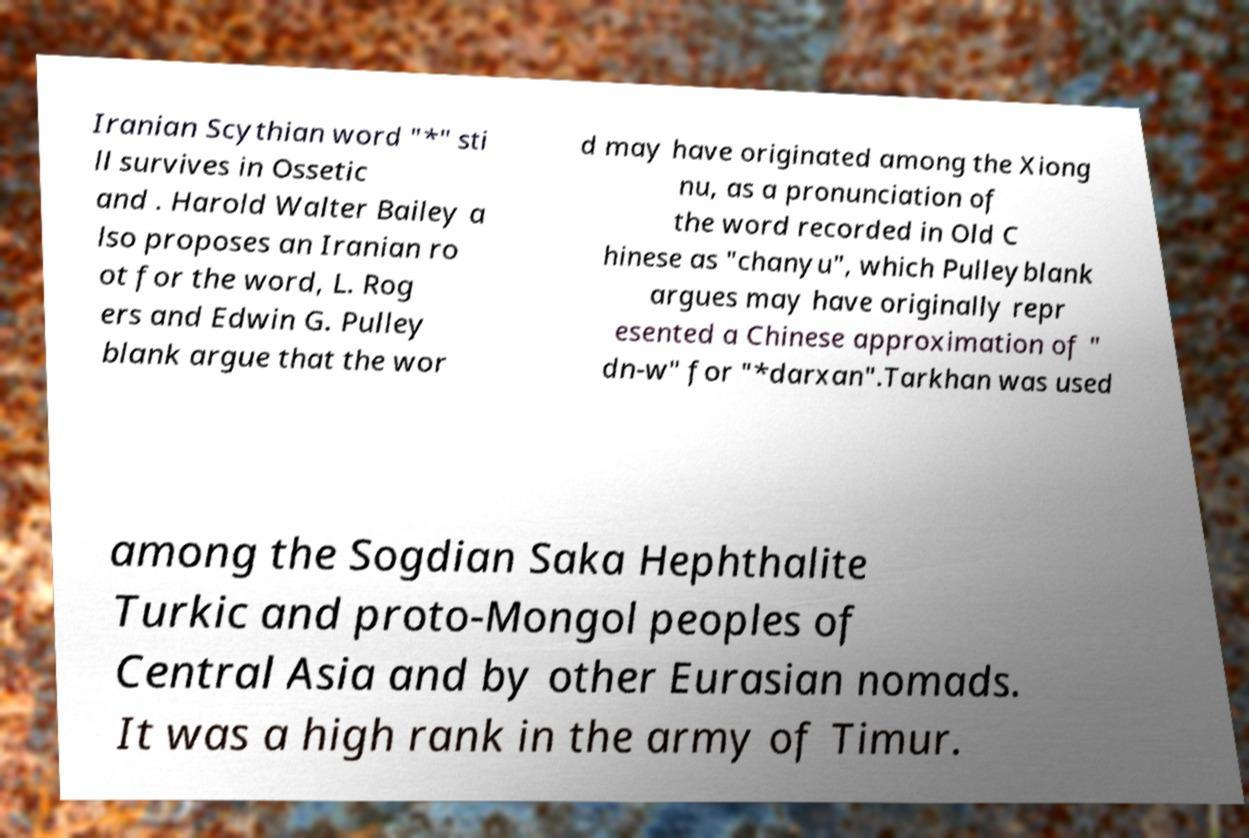Could you assist in decoding the text presented in this image and type it out clearly? Iranian Scythian word "*" sti ll survives in Ossetic and . Harold Walter Bailey a lso proposes an Iranian ro ot for the word, L. Rog ers and Edwin G. Pulley blank argue that the wor d may have originated among the Xiong nu, as a pronunciation of the word recorded in Old C hinese as "chanyu", which Pulleyblank argues may have originally repr esented a Chinese approximation of " dn-w" for "*darxan".Tarkhan was used among the Sogdian Saka Hephthalite Turkic and proto-Mongol peoples of Central Asia and by other Eurasian nomads. It was a high rank in the army of Timur. 